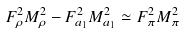<formula> <loc_0><loc_0><loc_500><loc_500>F ^ { 2 } _ { \rho } M ^ { 2 } _ { \rho } - F ^ { 2 } _ { a _ { 1 } } M ^ { 2 } _ { a _ { 1 } } \simeq F ^ { 2 } _ { \pi } M ^ { 2 } _ { \pi }</formula> 